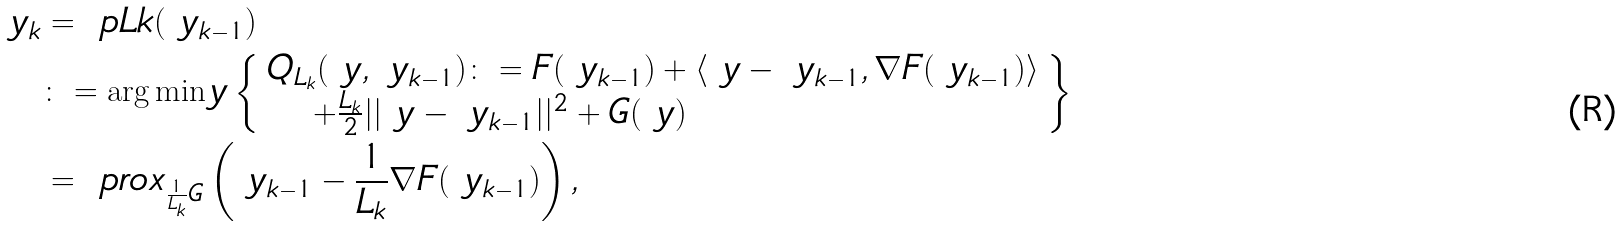<formula> <loc_0><loc_0><loc_500><loc_500>\ y _ { k } & = \ p L k ( \ y _ { k - 1 } ) \\ & \colon = \arg \min _ { \ } y \left \{ \begin{array} { l } Q _ { L _ { k } } ( \ y , \ y _ { k - 1 } ) \colon = F ( \ y _ { k - 1 } ) + \langle \ y - \ y _ { k - 1 } , \nabla F ( \ y _ { k - 1 } ) \rangle \\ \quad \, + \frac { L _ { k } } { 2 } | | \ y - \ y _ { k - 1 } | | ^ { 2 } + G ( \ y ) \end{array} \right \} \\ & = \ p r o x _ { \frac { 1 } { L _ { k } } G } \left ( \ y _ { k - 1 } - \frac { 1 } { L _ { k } } \nabla F ( \ y _ { k - 1 } ) \right ) ,</formula> 